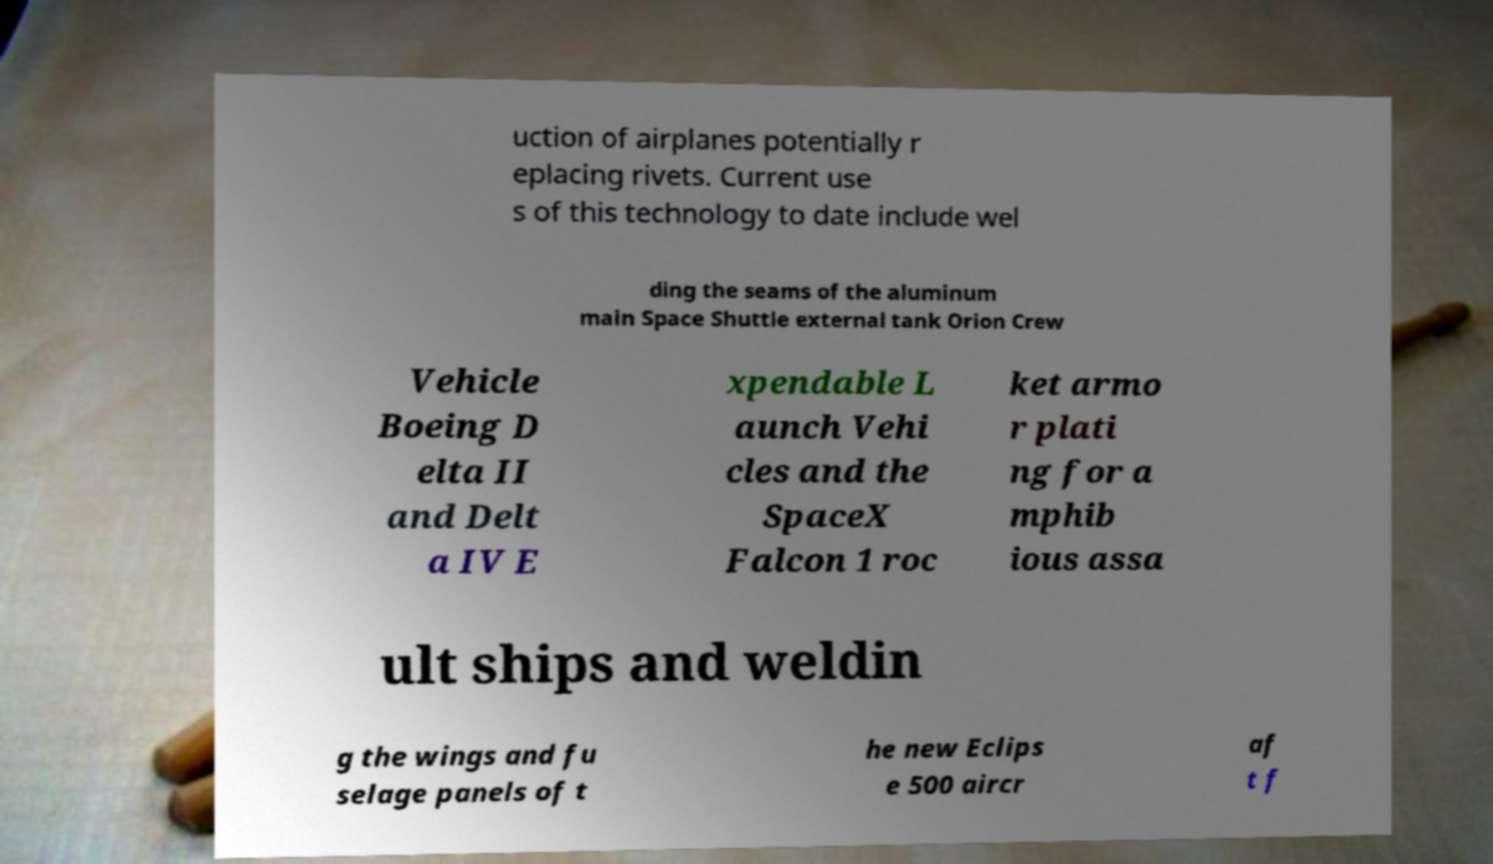Can you accurately transcribe the text from the provided image for me? uction of airplanes potentially r eplacing rivets. Current use s of this technology to date include wel ding the seams of the aluminum main Space Shuttle external tank Orion Crew Vehicle Boeing D elta II and Delt a IV E xpendable L aunch Vehi cles and the SpaceX Falcon 1 roc ket armo r plati ng for a mphib ious assa ult ships and weldin g the wings and fu selage panels of t he new Eclips e 500 aircr af t f 